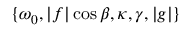<formula> <loc_0><loc_0><loc_500><loc_500>\{ \omega _ { 0 } , | f | \cos \beta , \kappa , \gamma , | g | \}</formula> 